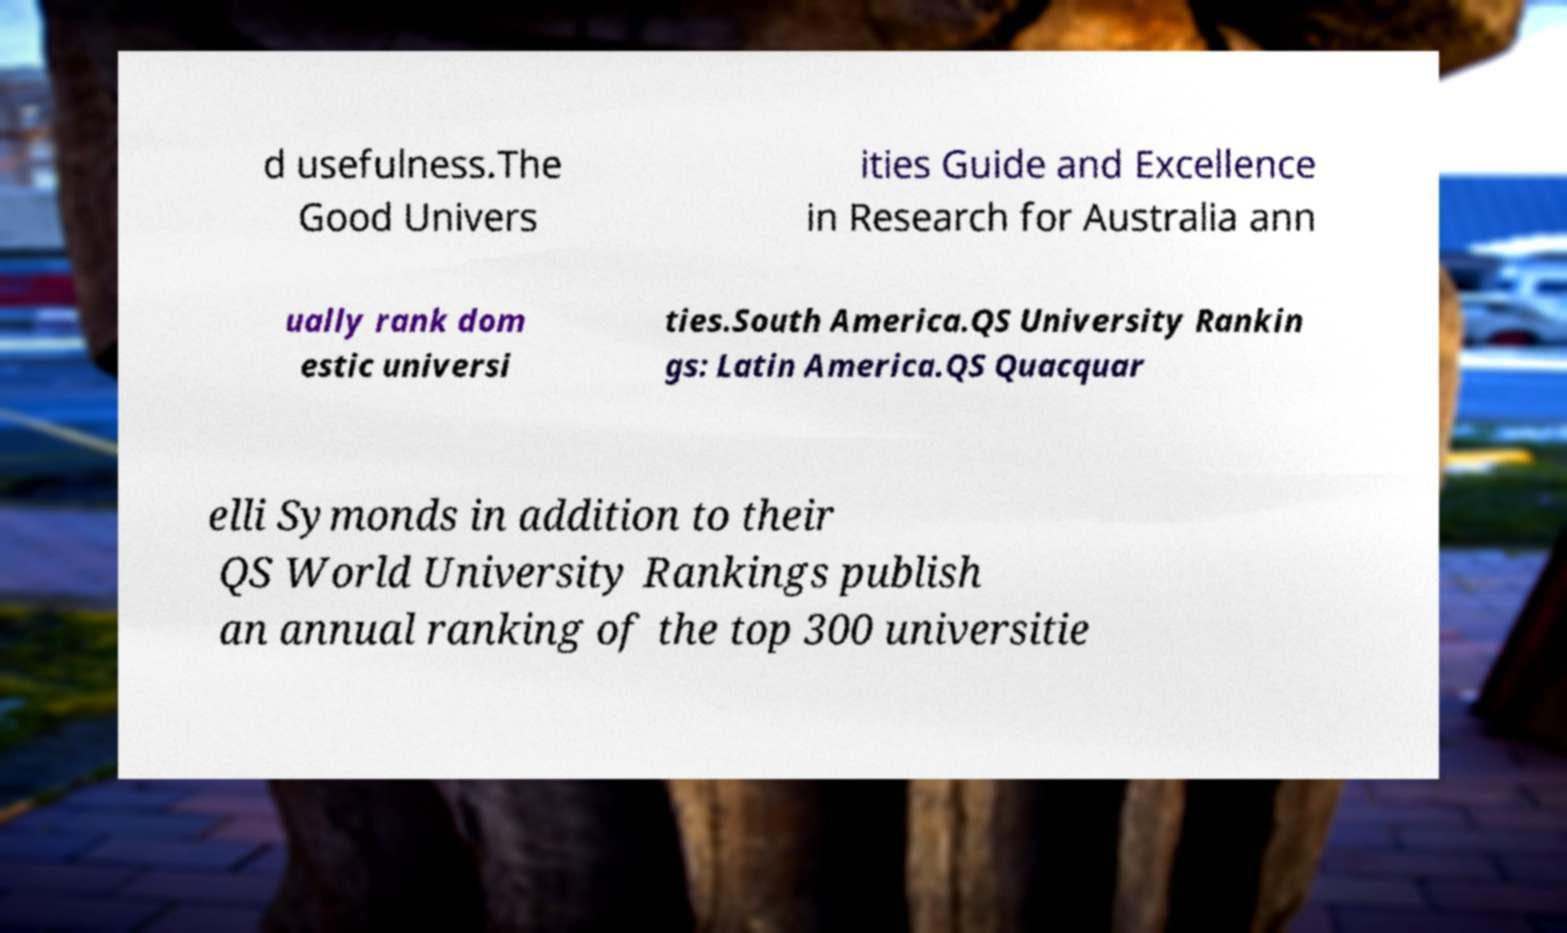Can you accurately transcribe the text from the provided image for me? d usefulness.The Good Univers ities Guide and Excellence in Research for Australia ann ually rank dom estic universi ties.South America.QS University Rankin gs: Latin America.QS Quacquar elli Symonds in addition to their QS World University Rankings publish an annual ranking of the top 300 universitie 